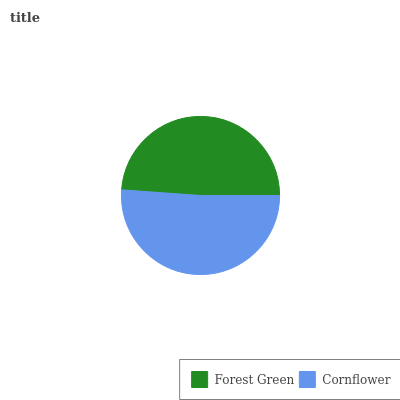Is Forest Green the minimum?
Answer yes or no. Yes. Is Cornflower the maximum?
Answer yes or no. Yes. Is Cornflower the minimum?
Answer yes or no. No. Is Cornflower greater than Forest Green?
Answer yes or no. Yes. Is Forest Green less than Cornflower?
Answer yes or no. Yes. Is Forest Green greater than Cornflower?
Answer yes or no. No. Is Cornflower less than Forest Green?
Answer yes or no. No. Is Cornflower the high median?
Answer yes or no. Yes. Is Forest Green the low median?
Answer yes or no. Yes. Is Forest Green the high median?
Answer yes or no. No. Is Cornflower the low median?
Answer yes or no. No. 